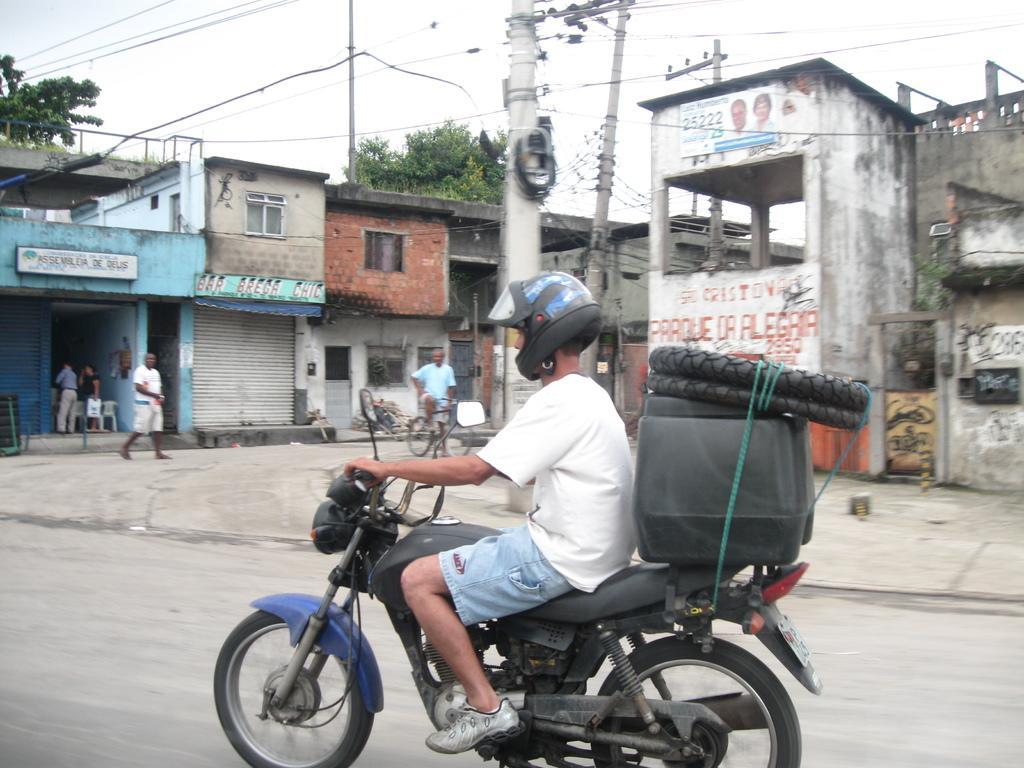Please provide a concise description of this image. There is a person riding a bike on the road and he wore a helmet. Here we can see a box, tires, buildings, boards, poles, wires, trees and few persons. There is a person on the bicycle. In the background there is sky. 